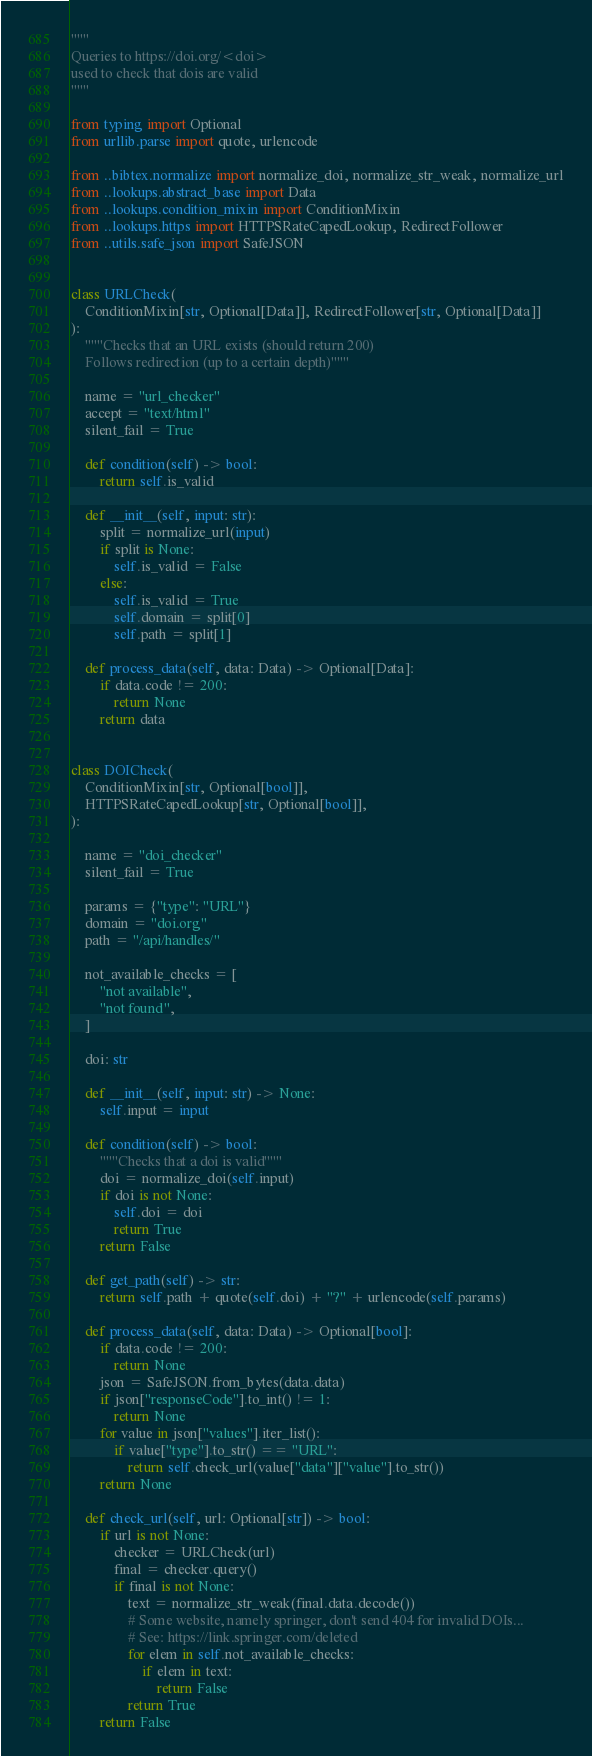Convert code to text. <code><loc_0><loc_0><loc_500><loc_500><_Python_>"""
Queries to https://doi.org/<doi>
used to check that dois are valid
"""

from typing import Optional
from urllib.parse import quote, urlencode

from ..bibtex.normalize import normalize_doi, normalize_str_weak, normalize_url
from ..lookups.abstract_base import Data
from ..lookups.condition_mixin import ConditionMixin
from ..lookups.https import HTTPSRateCapedLookup, RedirectFollower
from ..utils.safe_json import SafeJSON


class URLCheck(
    ConditionMixin[str, Optional[Data]], RedirectFollower[str, Optional[Data]]
):
    """Checks that an URL exists (should return 200)
    Follows redirection (up to a certain depth)"""

    name = "url_checker"
    accept = "text/html"
    silent_fail = True

    def condition(self) -> bool:
        return self.is_valid

    def __init__(self, input: str):
        split = normalize_url(input)
        if split is None:
            self.is_valid = False
        else:
            self.is_valid = True
            self.domain = split[0]
            self.path = split[1]

    def process_data(self, data: Data) -> Optional[Data]:
        if data.code != 200:
            return None
        return data


class DOICheck(
    ConditionMixin[str, Optional[bool]],
    HTTPSRateCapedLookup[str, Optional[bool]],
):

    name = "doi_checker"
    silent_fail = True

    params = {"type": "URL"}
    domain = "doi.org"
    path = "/api/handles/"

    not_available_checks = [
        "not available",
        "not found",
    ]

    doi: str

    def __init__(self, input: str) -> None:
        self.input = input

    def condition(self) -> bool:
        """Checks that a doi is valid"""
        doi = normalize_doi(self.input)
        if doi is not None:
            self.doi = doi
            return True
        return False

    def get_path(self) -> str:
        return self.path + quote(self.doi) + "?" + urlencode(self.params)

    def process_data(self, data: Data) -> Optional[bool]:
        if data.code != 200:
            return None
        json = SafeJSON.from_bytes(data.data)
        if json["responseCode"].to_int() != 1:
            return None
        for value in json["values"].iter_list():
            if value["type"].to_str() == "URL":
                return self.check_url(value["data"]["value"].to_str())
        return None

    def check_url(self, url: Optional[str]) -> bool:
        if url is not None:
            checker = URLCheck(url)
            final = checker.query()
            if final is not None:
                text = normalize_str_weak(final.data.decode())
                # Some website, namely springer, don't send 404 for invalid DOIs...
                # See: https://link.springer.com/deleted
                for elem in self.not_available_checks:
                    if elem in text:
                        return False
                return True
        return False
</code> 